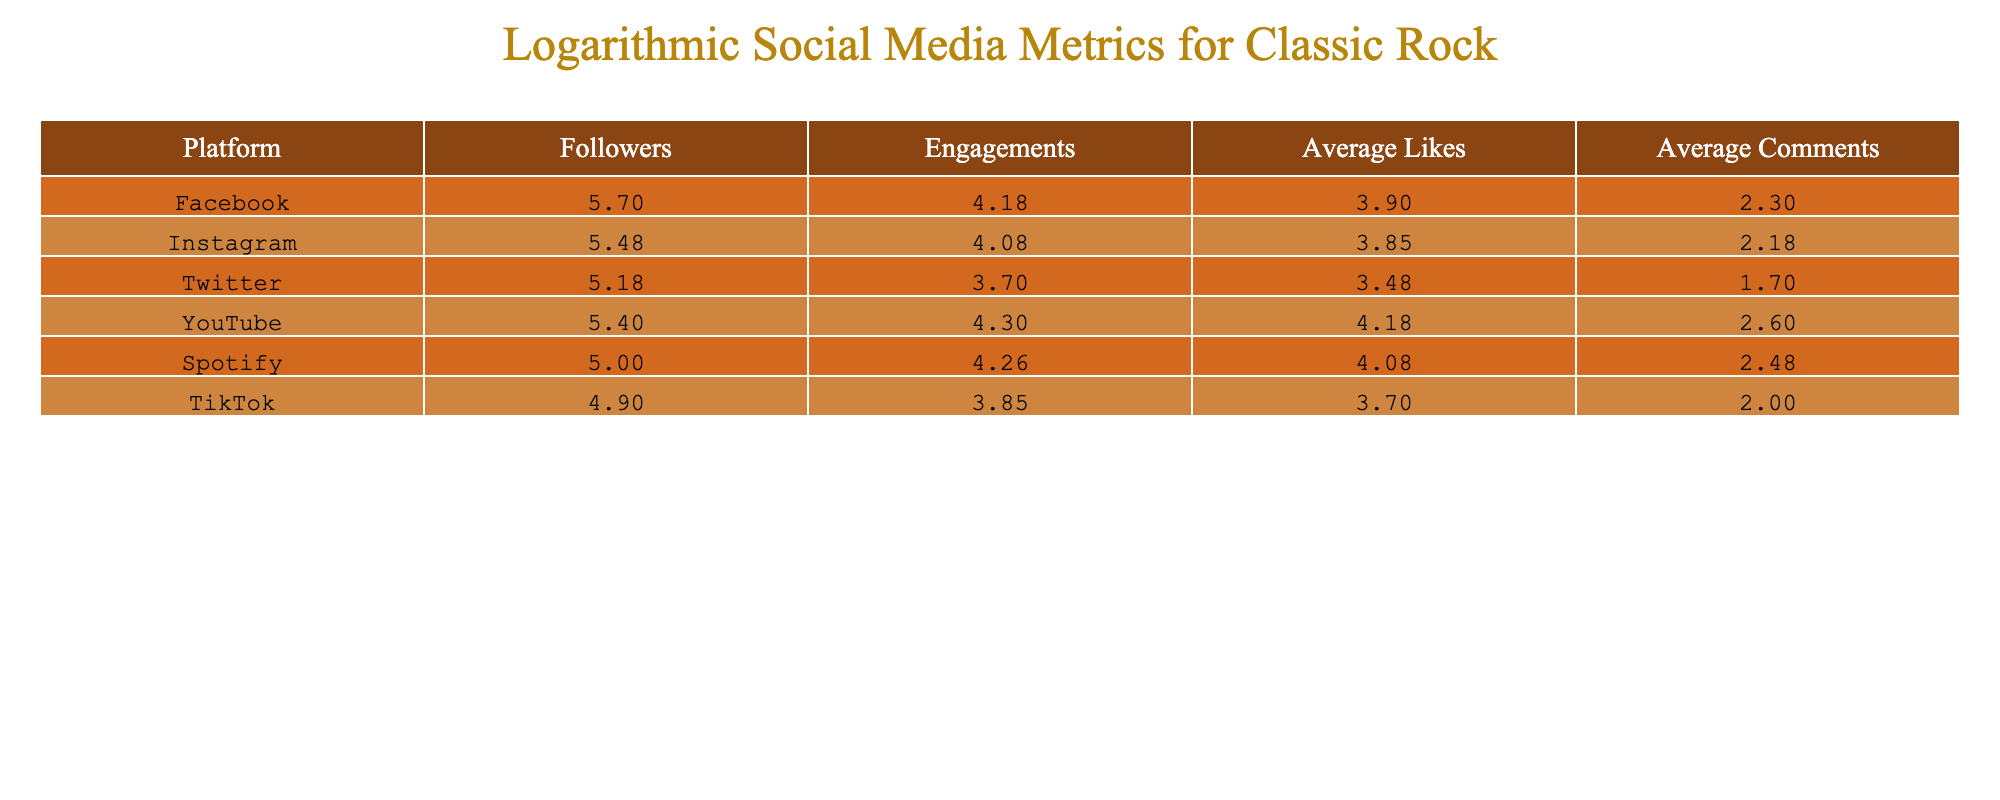What is the logarithmic value of the number of followers on YouTube? The number of followers on YouTube is 250000. Taking the logarithm base 10, log10(250000) equals approximately 5.398.
Answer: 5.398 Which platform has the highest average likes? Checking the average likes for each platform shows that YouTube has the highest average likes at 15000.
Answer: YouTube What is the total engagement for Facebook and Spotify combined? The engagements for Facebook are 15000 and for Spotify, 18000. Adding them gives 15000 + 18000 = 33000.
Answer: 33000 Is the average comments on Instagram greater than on TikTok? The average comments on Instagram are 150, while TikTok has an average of 100. 150 is greater than 100, confirming the statement.
Answer: Yes What is the difference in logarithmic values of average likes between Facebook and Twitter? Facebook's average likes are 8000 and Twitter's are 3000. Taking their logarithmic values: log10(8000) is approximately 3.903, and log10(3000) is approximately 3.477. The difference is 3.903 - 3.477 = 0.426.
Answer: 0.426 Which platform has the least number of engagements after logarithmic transformation? First, we review the engagements: TikTok has 7000, which is less than all others. Its logarithmic value is log10(7000) which gives approximately 3.845, making it the least.
Answer: TikTok How do average comments on YouTube compare to Spotify? For YouTube, the average comments are 400, while on Spotify, they are 300. Therefore, YouTube's average comments are higher than Spotify's by 100.
Answer: YouTube has more average comments What is the average logarithmic value of engagements across all platforms? The engagements are 15000 (Facebook), 12000 (Instagram), 5000 (Twitter), 20000 (YouTube), 18000 (Spotify), and 7000 (TikTok). First, take their logarithmic values, which are approximately 4.176, 4.079, 3.699, 4.301, 4.255, and 3.845 respectively. The average is then calculated as (4.176 + 4.079 + 3.699 + 4.301 + 4.255 + 3.845) / 6, yielding approximately 4.176.
Answer: 4.176 Which social media platform has the most followers after applying the logarithm? Facebook has 500000 followers, which gives the logarithmic value log10(500000) approximately 5.699. Comparing this with others shows it has the highest value.
Answer: Facebook 